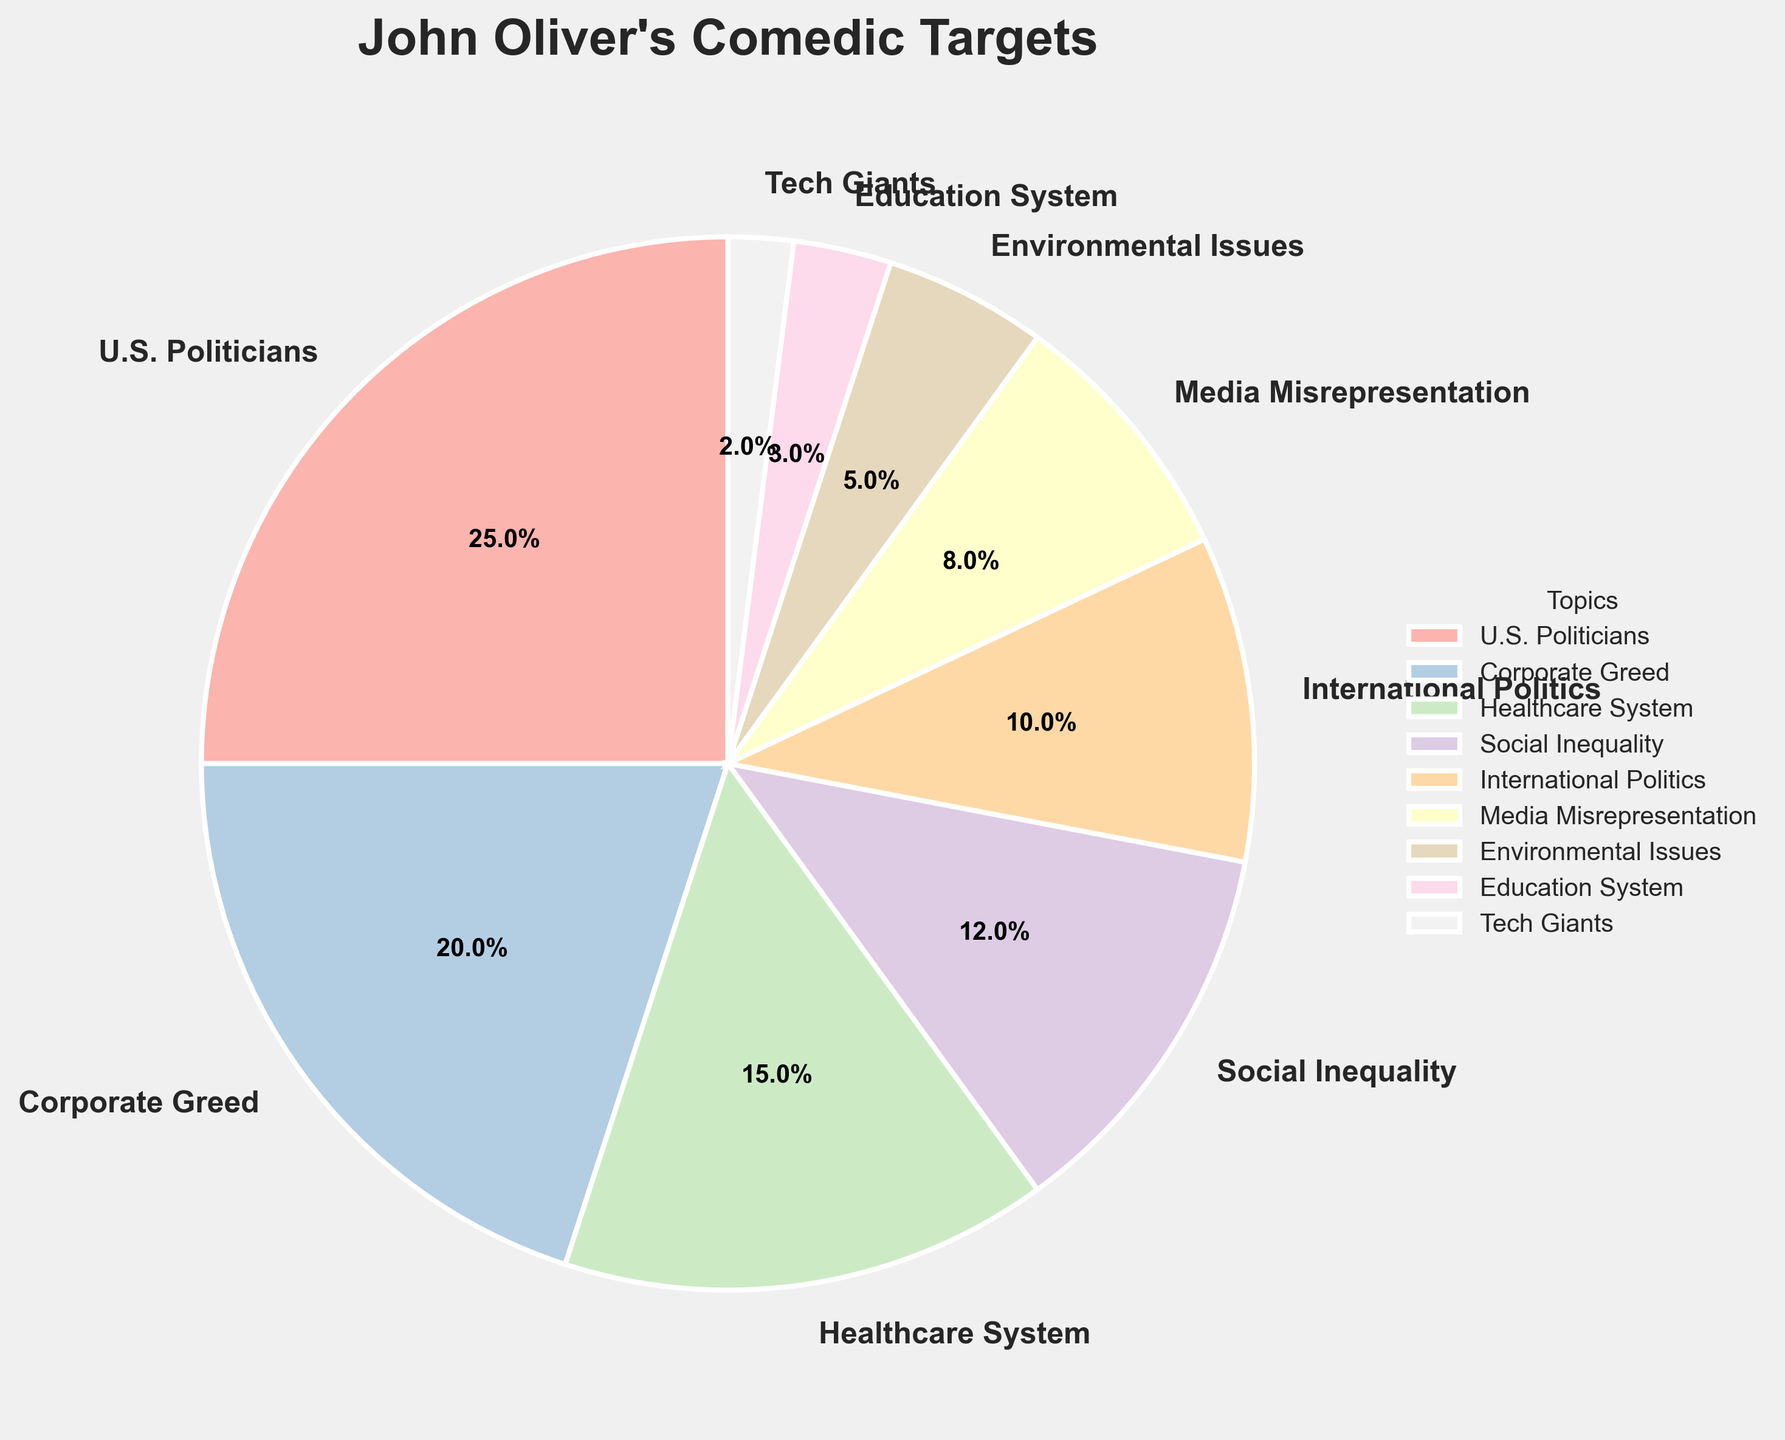Which topic does John Oliver target the most? To determine the most targeted topic, identify the segment with the highest percentage in the pie chart. "U.S. Politicians" has the largest segment at 25%.
Answer: U.S. Politicians What is the combined percentage of John Oliver's comedic targets on "Corporate Greed" and the "Healthcare System"? Locate the percentages for "Corporate Greed" (20%) and "Healthcare System" (15%), then add them together: 20% + 15% = 35%.
Answer: 35% How much more does John Oliver target U.S. Politicians compared to Social Inequality? Find the percentages for "U.S. Politicians" (25%) and "Social Inequality" (12%), then subtract the smaller from the larger: 25% - 12% = 13%.
Answer: 13% Which target has the smallest percentage in the pie chart? Identify the segment with the lowest percentage, which is "Tech Giants" at 2%.
Answer: Tech Giants Are there more comedic targets related to domestic issues or international politics? Sum the percentages for domestic issues ("U.S. Politicians" 25%, "Corporate Greed" 20%, "Healthcare System" 15%, "Social Inequality" 12%, "Media Misrepresentation" 8%, "Environmental Issues" 5%, "Education System" 3%, "Tech Giants" 2%) and compare it to "International Politics" (10%). Domestic issues: 25% + 20% + 15% + 12% + 8% + 5% + 3% + 2% = 90%, International Politics: 10%.
Answer: Domestic issues Which comedic target has a segment color closest to pink on the pie chart? Evaluate the visual colors in the pie chart. The segment for "Corporate Greed" appears to be in a light pink shade.
Answer: Corporate Greed How much combined percentage is spent on Environmental Issues and Education System? Find the percentages for "Environmental Issues" (5%) and "Education System" (3%), then add them together: 5% + 3% = 8%.
Answer: 8% Is John Oliver more likely to target Media Misrepresentation or International Politics? Compare the percentages of "Media Misrepresentation" (8%) and "International Politics" (10%). "International Politics" is slightly more targeted.
Answer: International Politics What percentage targets involve issues outside of the U.S.? Identify and sum the percentages related to non-U.S. issues: "International Politics" (10%).
Answer: 10% What is the percentage difference between targets on Social Inequality and Environmental Issues? Find the percentages of "Social Inequality" (12%) and "Environmental Issues" (5%), then subtract the smaller from the larger: 12% - 5% = 7%.
Answer: 7% 